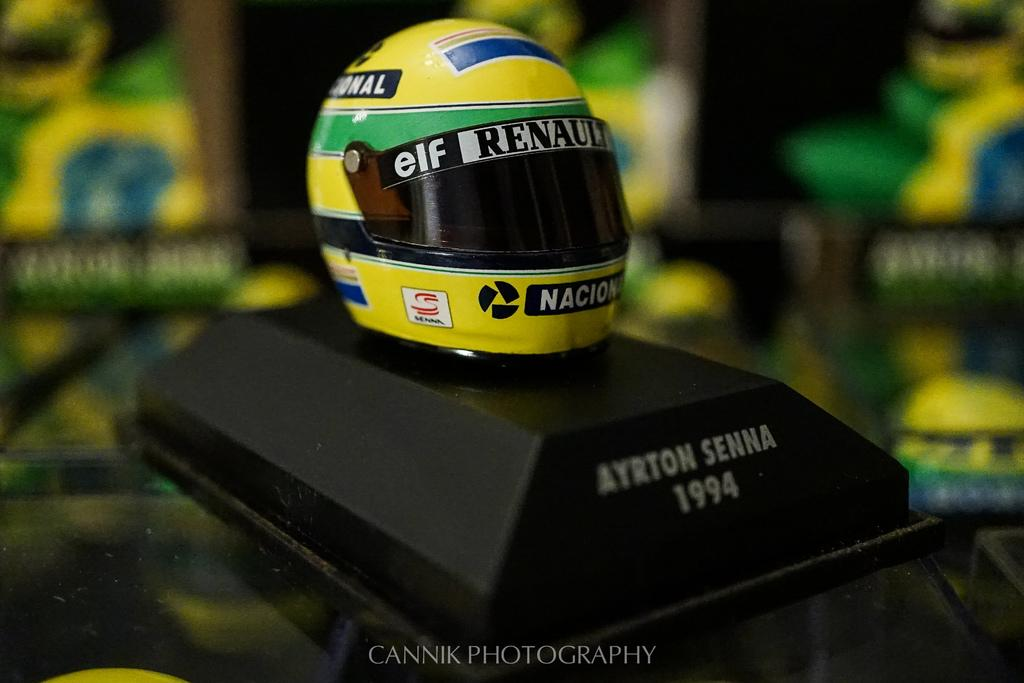What object is present in the image? There is a helmet in the image. How is the helmet positioned in the image? The helmet is placed on a stand. What type of throat-soothing remedy is present in the image? There is no throat-soothing remedy present in the image; it only features a helmet placed on a stand. 